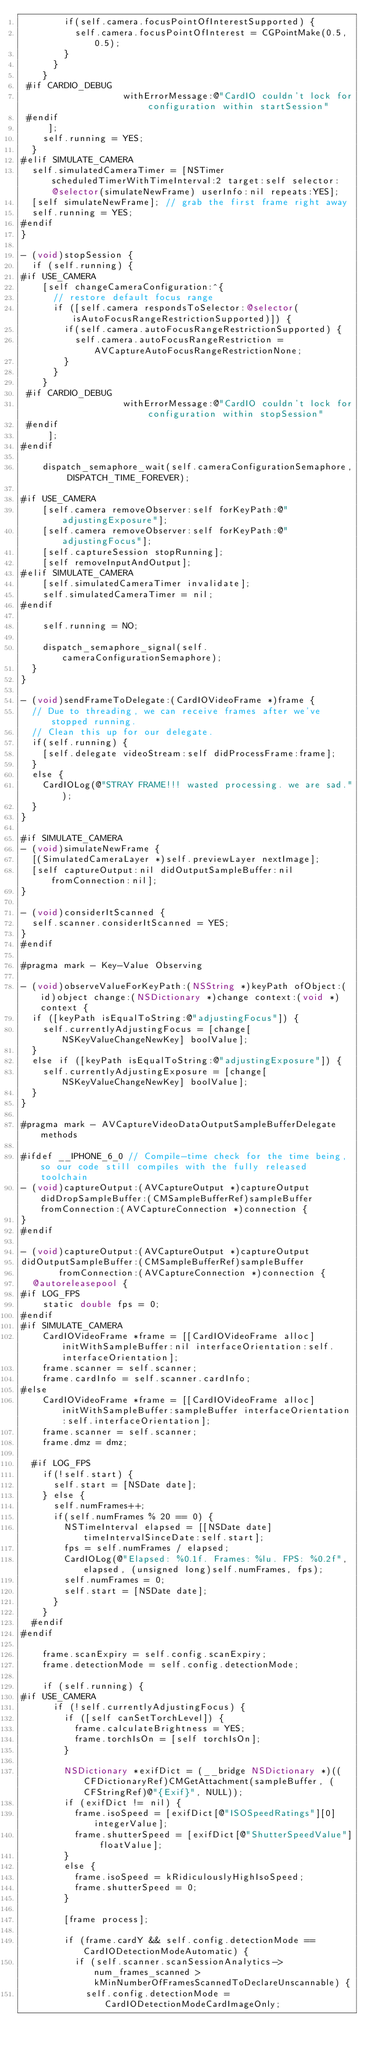Convert code to text. <code><loc_0><loc_0><loc_500><loc_500><_ObjectiveC_>        if(self.camera.focusPointOfInterestSupported) {
          self.camera.focusPointOfInterest = CGPointMake(0.5, 0.5);
        }
      }
    }
 #if CARDIO_DEBUG
                   withErrorMessage:@"CardIO couldn't lock for configuration within startSession"
 #endif
     ];
    self.running = YES;
  }
#elif SIMULATE_CAMERA
  self.simulatedCameraTimer = [NSTimer scheduledTimerWithTimeInterval:2 target:self selector:@selector(simulateNewFrame) userInfo:nil repeats:YES];
  [self simulateNewFrame]; // grab the first frame right away
  self.running = YES;
#endif
}

- (void)stopSession {
  if (self.running) {
#if USE_CAMERA
    [self changeCameraConfiguration:^{
      // restore default focus range
      if ([self.camera respondsToSelector:@selector(isAutoFocusRangeRestrictionSupported)]) {
        if(self.camera.autoFocusRangeRestrictionSupported) {
          self.camera.autoFocusRangeRestriction = AVCaptureAutoFocusRangeRestrictionNone;
        }
      }
    }
 #if CARDIO_DEBUG
                   withErrorMessage:@"CardIO couldn't lock for configuration within stopSession"
 #endif
     ];
#endif

    dispatch_semaphore_wait(self.cameraConfigurationSemaphore, DISPATCH_TIME_FOREVER);

#if USE_CAMERA
    [self.camera removeObserver:self forKeyPath:@"adjustingExposure"];
    [self.camera removeObserver:self forKeyPath:@"adjustingFocus"];
    [self.captureSession stopRunning];
    [self removeInputAndOutput];
#elif SIMULATE_CAMERA
    [self.simulatedCameraTimer invalidate];
    self.simulatedCameraTimer = nil;
#endif

    self.running = NO;

    dispatch_semaphore_signal(self.cameraConfigurationSemaphore);
  }
}

- (void)sendFrameToDelegate:(CardIOVideoFrame *)frame {
  // Due to threading, we can receive frames after we've stopped running.
  // Clean this up for our delegate.
  if(self.running) {
    [self.delegate videoStream:self didProcessFrame:frame];
  }
  else {
    CardIOLog(@"STRAY FRAME!!! wasted processing. we are sad.");
  }
}

#if SIMULATE_CAMERA
- (void)simulateNewFrame {
  [(SimulatedCameraLayer *)self.previewLayer nextImage];
  [self captureOutput:nil didOutputSampleBuffer:nil fromConnection:nil];
}

- (void)considerItScanned {
  self.scanner.considerItScanned = YES;
}
#endif

#pragma mark - Key-Value Observing

- (void)observeValueForKeyPath:(NSString *)keyPath ofObject:(id)object change:(NSDictionary *)change context:(void *)context {
  if ([keyPath isEqualToString:@"adjustingFocus"]) {
    self.currentlyAdjustingFocus = [change[NSKeyValueChangeNewKey] boolValue];
  }
  else if ([keyPath isEqualToString:@"adjustingExposure"]) {
    self.currentlyAdjustingExposure = [change[NSKeyValueChangeNewKey] boolValue];
  }
}

#pragma mark - AVCaptureVideoDataOutputSampleBufferDelegate methods

#ifdef __IPHONE_6_0 // Compile-time check for the time being, so our code still compiles with the fully released toolchain
- (void)captureOutput:(AVCaptureOutput *)captureOutput didDropSampleBuffer:(CMSampleBufferRef)sampleBuffer fromConnection:(AVCaptureConnection *)connection {
}
#endif

- (void)captureOutput:(AVCaptureOutput *)captureOutput
didOutputSampleBuffer:(CMSampleBufferRef)sampleBuffer
       fromConnection:(AVCaptureConnection *)connection {
  @autoreleasepool {
#if LOG_FPS
    static double fps = 0;
#endif
#if SIMULATE_CAMERA
    CardIOVideoFrame *frame = [[CardIOVideoFrame alloc] initWithSampleBuffer:nil interfaceOrientation:self.interfaceOrientation];
    frame.scanner = self.scanner;
    frame.cardInfo = self.scanner.cardInfo;
#else
    CardIOVideoFrame *frame = [[CardIOVideoFrame alloc] initWithSampleBuffer:sampleBuffer interfaceOrientation:self.interfaceOrientation];
    frame.scanner = self.scanner;
    frame.dmz = dmz;

  #if LOG_FPS
    if(!self.start) {
      self.start = [NSDate date];
    } else {
      self.numFrames++;
      if(self.numFrames % 20 == 0) {
        NSTimeInterval elapsed = [[NSDate date] timeIntervalSinceDate:self.start];
        fps = self.numFrames / elapsed;
        CardIOLog(@"Elapsed: %0.1f. Frames: %lu. FPS: %0.2f", elapsed, (unsigned long)self.numFrames, fps);
        self.numFrames = 0;
        self.start = [NSDate date];
      }
    }
  #endif
#endif

    frame.scanExpiry = self.config.scanExpiry;
    frame.detectionMode = self.config.detectionMode;

    if (self.running) {
#if USE_CAMERA
      if (!self.currentlyAdjustingFocus) {
        if ([self canSetTorchLevel]) {
          frame.calculateBrightness = YES;
          frame.torchIsOn = [self torchIsOn];
        }

        NSDictionary *exifDict = (__bridge NSDictionary *)((CFDictionaryRef)CMGetAttachment(sampleBuffer, (CFStringRef)@"{Exif}", NULL));
        if (exifDict != nil) {
          frame.isoSpeed = [exifDict[@"ISOSpeedRatings"][0] integerValue];
          frame.shutterSpeed = [exifDict[@"ShutterSpeedValue"] floatValue];
        }
        else {
          frame.isoSpeed = kRidiculouslyHighIsoSpeed;
          frame.shutterSpeed = 0;
        }

        [frame process];

        if (frame.cardY && self.config.detectionMode == CardIODetectionModeAutomatic) {
          if (self.scanner.scanSessionAnalytics->num_frames_scanned > kMinNumberOfFramesScannedToDeclareUnscannable) {
            self.config.detectionMode = CardIODetectionModeCardImageOnly;</code> 